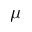<formula> <loc_0><loc_0><loc_500><loc_500>\mu</formula> 